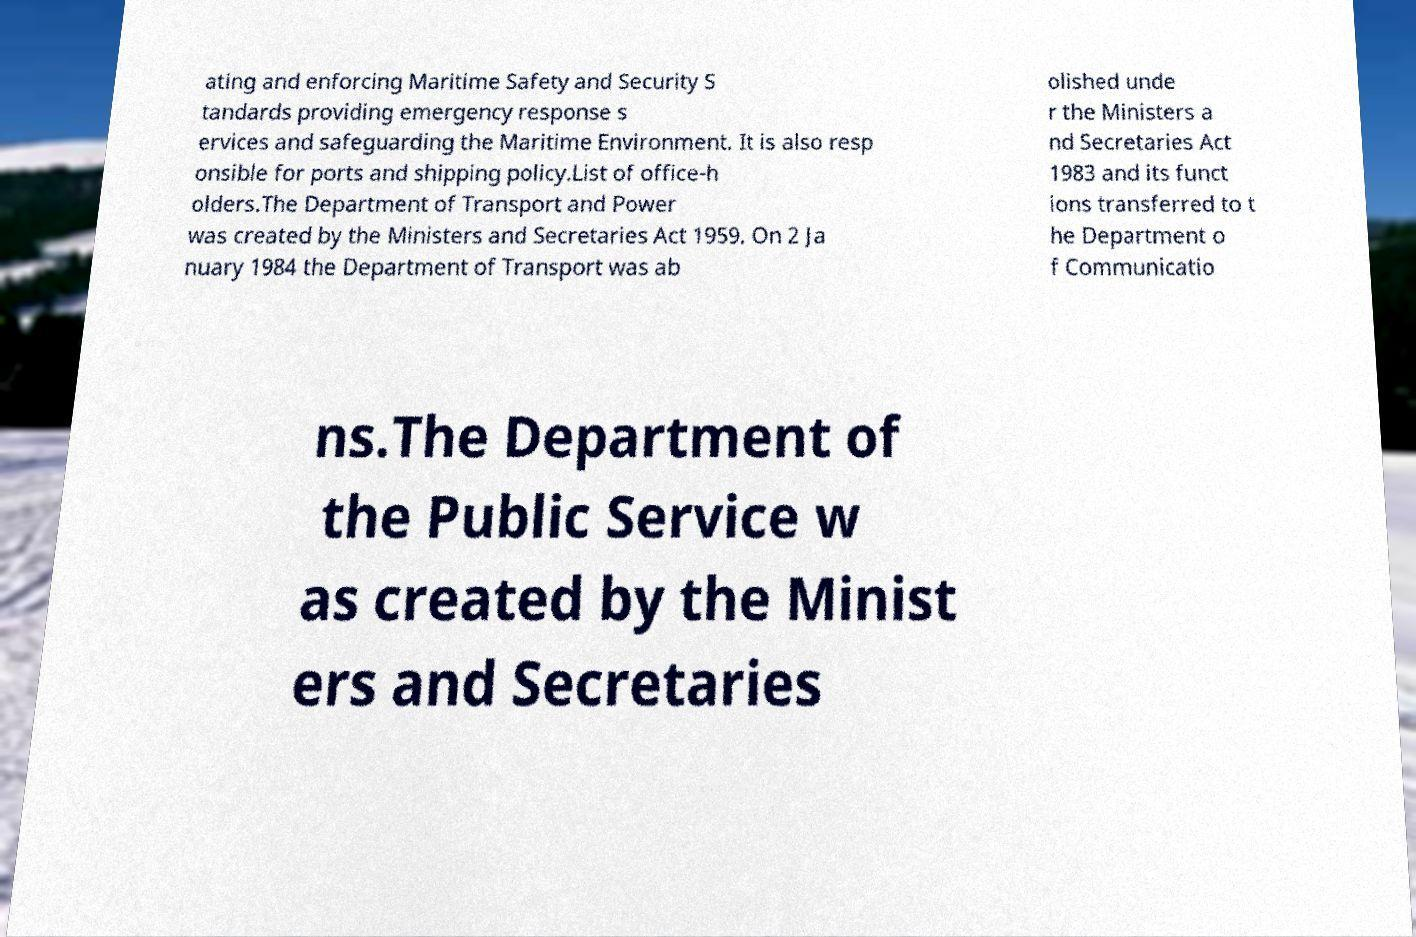Can you accurately transcribe the text from the provided image for me? ating and enforcing Maritime Safety and Security S tandards providing emergency response s ervices and safeguarding the Maritime Environment. It is also resp onsible for ports and shipping policy.List of office-h olders.The Department of Transport and Power was created by the Ministers and Secretaries Act 1959. On 2 Ja nuary 1984 the Department of Transport was ab olished unde r the Ministers a nd Secretaries Act 1983 and its funct ions transferred to t he Department o f Communicatio ns.The Department of the Public Service w as created by the Minist ers and Secretaries 